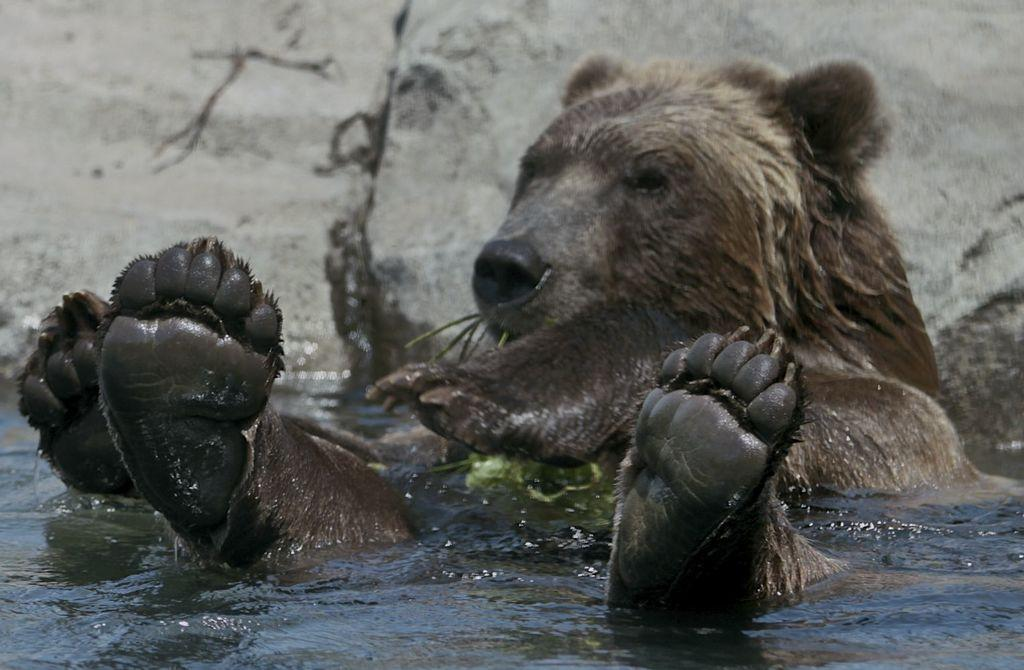What animal is present in the image? There is a bear in the image. What is the bear doing in the image? The bear is sitting on the water and showing its legs. What else can be seen in the image besides the bear? There are stones visible on the back in the image. How does the beetle compare to the bear in terms of size in the image? There is no beetle present in the image, so it cannot be compared to the bear in terms of size. 